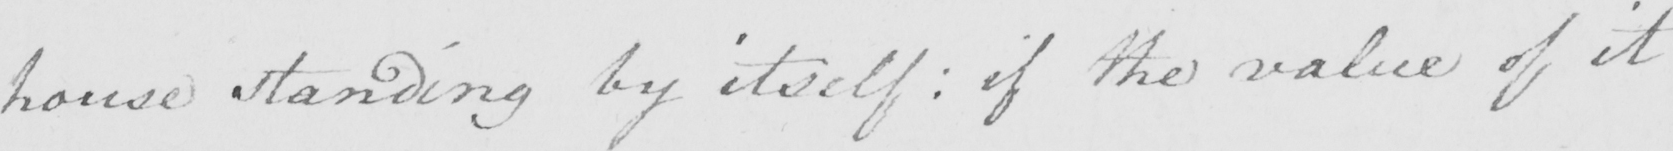What is written in this line of handwriting? house standing by itself :  if the value of it 